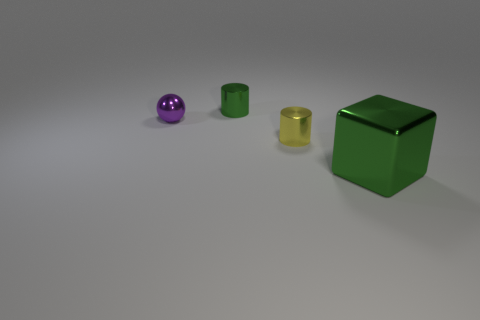Add 3 blue matte blocks. How many objects exist? 7 Subtract all spheres. How many objects are left? 3 Subtract 0 brown spheres. How many objects are left? 4 Subtract all yellow things. Subtract all cubes. How many objects are left? 2 Add 1 yellow objects. How many yellow objects are left? 2 Add 1 balls. How many balls exist? 2 